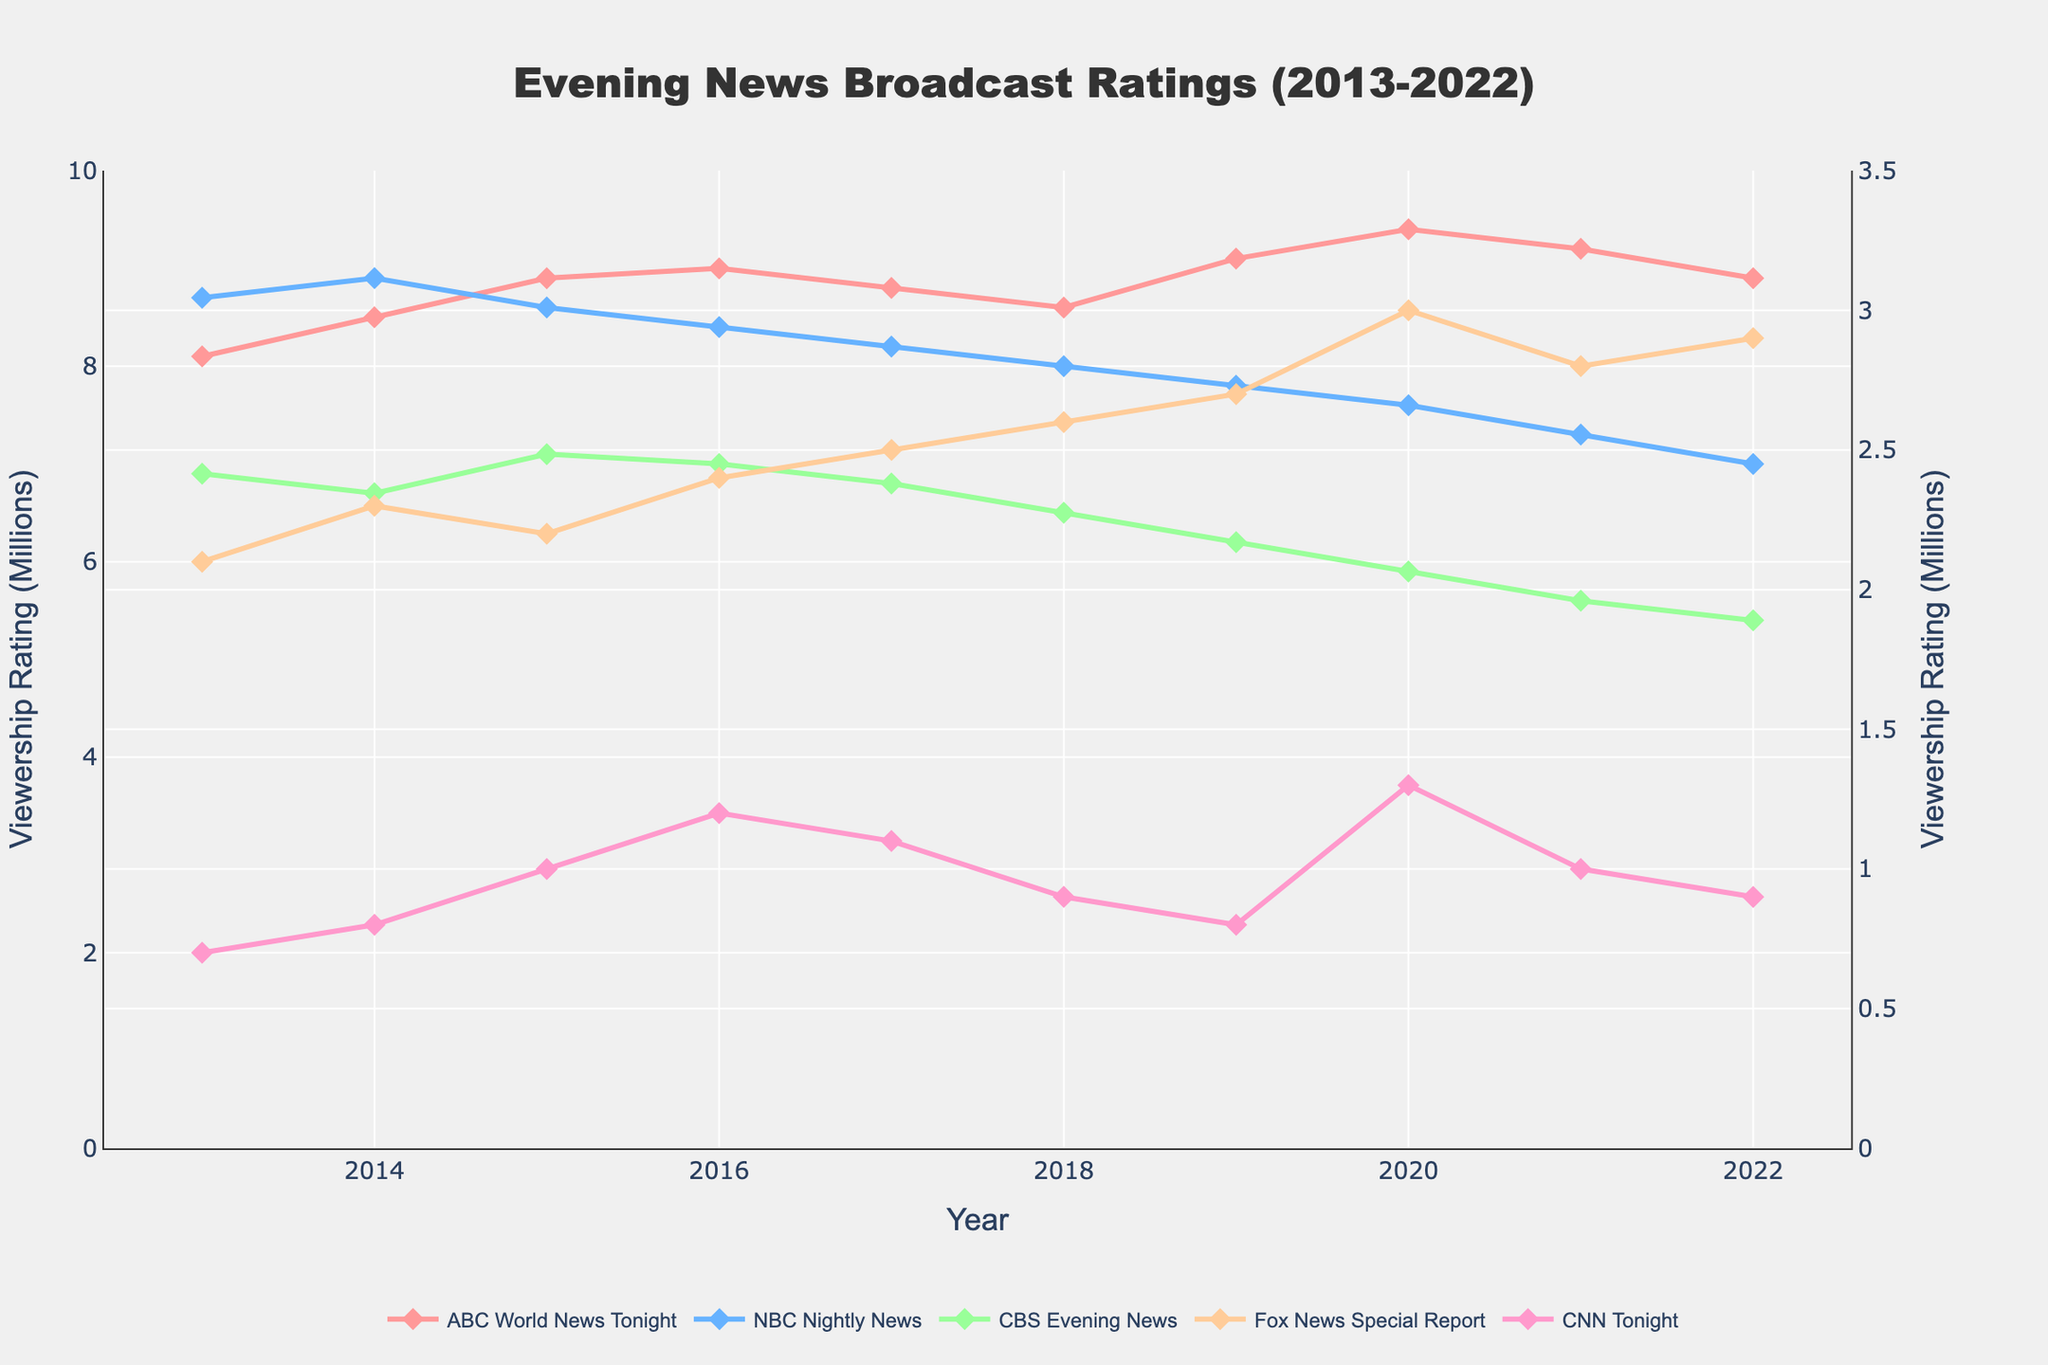Which network had the highest viewership rating in 2015? In 2015, the data shows the viewership ratings for all networks. By comparing the values, we can see ABC World News Tonight had the highest rating at 8.9 million viewers.
Answer: ABC World News Tonight How did the viewership rating of CNN Tonight change from 2013 to 2022? The rating for CNN Tonight started at 0.7 million viewers in 2013 and changed to 0.9 million viewers in 2022. By subtracting, we find the change: 0.9 - 0.7 = 0.2 million viewers.
Answer: Increased by 0.2 million viewers Which network showed a decreasing trend in viewership ratings from 2015 to 2022? Tracking the viewership ratings from 2015 to 2022, we can see that NBC Nightly News dropped from 8.6 million in 2015 to 7.0 million in 2022.
Answer: NBC Nightly News In which year did Fox News Special Report have its lowest viewership rating? The data points out various viewership ratings for Fox News Special Report from year to year. The lowest rating, 2.1 million viewers, occurred in 2013.
Answer: 2013 What is the range of viewership ratings for CBS Evening News over the decade? To determine the range, we find the maximum and minimum ratings for CBS Evening News from 2013 to 2022, which are 7.1 million and 5.4 million, respectively. The range is the difference between these two values: 7.1 - 5.4 = 1.7 million viewers.
Answer: 1.7 million viewers What was the average viewership rating for ABC World News Tonight over the decade? Summing up the viewership ratings for ABC World News Tonight from 2013 to 2022 gives us a total of 88.5. Dividing by the number of years (10), the average is 88.5 / 10 = 8.85 million viewers.
Answer: 8.85 million viewers How did the viewership rating for NBC Nightly News in 2020 compare to 2021? In 2020, NBC Nightly News had a rating of 7.6 million viewers and this dropped to 7.3 million viewers in 2021. The difference is 7.6 - 7.3 = 0.3 million viewers.
Answer: Dropped by 0.3 million viewers Which year saw the highest overall viewership rating across all networks combined? To find the highest overall viewership, we sum the ratings for each year and compare. The highest combined rating is in 2020 with 9.4 (ABC) + 7.6 (NBC) + 5.9 (CBS) + 3.0 (Fox) + 1.3 (CNN) = 27.2 million viewers.
Answer: 2020 What pattern can you observe from the viewership ratings of Fox News Special Report over the years? The viewership ratings of Fox News Special Report show a consistent increase from 2.1 million in 2013 to 2.9 million in 2022, with minor fluctuations along the way.
Answer: Increasing trend Compare the trend in viewership ratings for ABC World News Tonight and CBS Evening News. ABC World News Tonight shows a general upward trend peaking in 2020, then slightly decreasing. CBS Evening News has a declining trend from 6.9 million in 2013 to 5.4 million in 2022.
Answer: ABC increasing, CBS decreasing 